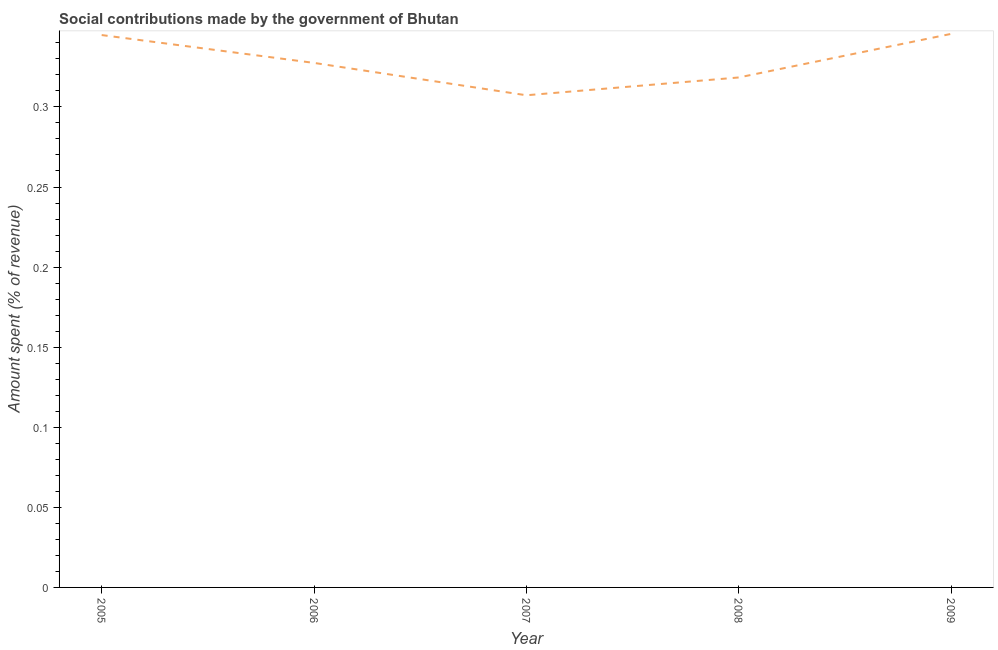What is the amount spent in making social contributions in 2009?
Offer a terse response. 0.35. Across all years, what is the maximum amount spent in making social contributions?
Offer a terse response. 0.35. Across all years, what is the minimum amount spent in making social contributions?
Your response must be concise. 0.31. In which year was the amount spent in making social contributions maximum?
Offer a very short reply. 2009. What is the sum of the amount spent in making social contributions?
Ensure brevity in your answer.  1.64. What is the difference between the amount spent in making social contributions in 2006 and 2007?
Offer a very short reply. 0.02. What is the average amount spent in making social contributions per year?
Offer a terse response. 0.33. What is the median amount spent in making social contributions?
Your response must be concise. 0.33. In how many years, is the amount spent in making social contributions greater than 0.13 %?
Your answer should be very brief. 5. What is the ratio of the amount spent in making social contributions in 2007 to that in 2008?
Offer a very short reply. 0.97. Is the amount spent in making social contributions in 2007 less than that in 2009?
Make the answer very short. Yes. What is the difference between the highest and the second highest amount spent in making social contributions?
Keep it short and to the point. 0. Is the sum of the amount spent in making social contributions in 2005 and 2008 greater than the maximum amount spent in making social contributions across all years?
Your answer should be compact. Yes. What is the difference between the highest and the lowest amount spent in making social contributions?
Ensure brevity in your answer.  0.04. In how many years, is the amount spent in making social contributions greater than the average amount spent in making social contributions taken over all years?
Provide a short and direct response. 2. How many lines are there?
Offer a terse response. 1. What is the difference between two consecutive major ticks on the Y-axis?
Keep it short and to the point. 0.05. Are the values on the major ticks of Y-axis written in scientific E-notation?
Your answer should be very brief. No. Does the graph contain any zero values?
Offer a terse response. No. What is the title of the graph?
Keep it short and to the point. Social contributions made by the government of Bhutan. What is the label or title of the X-axis?
Your answer should be very brief. Year. What is the label or title of the Y-axis?
Offer a terse response. Amount spent (% of revenue). What is the Amount spent (% of revenue) of 2005?
Give a very brief answer. 0.34. What is the Amount spent (% of revenue) of 2006?
Provide a short and direct response. 0.33. What is the Amount spent (% of revenue) of 2007?
Your answer should be very brief. 0.31. What is the Amount spent (% of revenue) of 2008?
Provide a succinct answer. 0.32. What is the Amount spent (% of revenue) of 2009?
Provide a succinct answer. 0.35. What is the difference between the Amount spent (% of revenue) in 2005 and 2006?
Offer a very short reply. 0.02. What is the difference between the Amount spent (% of revenue) in 2005 and 2007?
Give a very brief answer. 0.04. What is the difference between the Amount spent (% of revenue) in 2005 and 2008?
Your response must be concise. 0.03. What is the difference between the Amount spent (% of revenue) in 2005 and 2009?
Make the answer very short. -0. What is the difference between the Amount spent (% of revenue) in 2006 and 2007?
Offer a terse response. 0.02. What is the difference between the Amount spent (% of revenue) in 2006 and 2008?
Your answer should be very brief. 0.01. What is the difference between the Amount spent (% of revenue) in 2006 and 2009?
Provide a succinct answer. -0.02. What is the difference between the Amount spent (% of revenue) in 2007 and 2008?
Your answer should be very brief. -0.01. What is the difference between the Amount spent (% of revenue) in 2007 and 2009?
Provide a short and direct response. -0.04. What is the difference between the Amount spent (% of revenue) in 2008 and 2009?
Provide a succinct answer. -0.03. What is the ratio of the Amount spent (% of revenue) in 2005 to that in 2006?
Offer a terse response. 1.05. What is the ratio of the Amount spent (% of revenue) in 2005 to that in 2007?
Offer a terse response. 1.12. What is the ratio of the Amount spent (% of revenue) in 2005 to that in 2008?
Your answer should be very brief. 1.08. What is the ratio of the Amount spent (% of revenue) in 2006 to that in 2007?
Give a very brief answer. 1.07. What is the ratio of the Amount spent (% of revenue) in 2006 to that in 2008?
Provide a succinct answer. 1.03. What is the ratio of the Amount spent (% of revenue) in 2006 to that in 2009?
Ensure brevity in your answer.  0.95. What is the ratio of the Amount spent (% of revenue) in 2007 to that in 2009?
Ensure brevity in your answer.  0.89. What is the ratio of the Amount spent (% of revenue) in 2008 to that in 2009?
Offer a terse response. 0.92. 